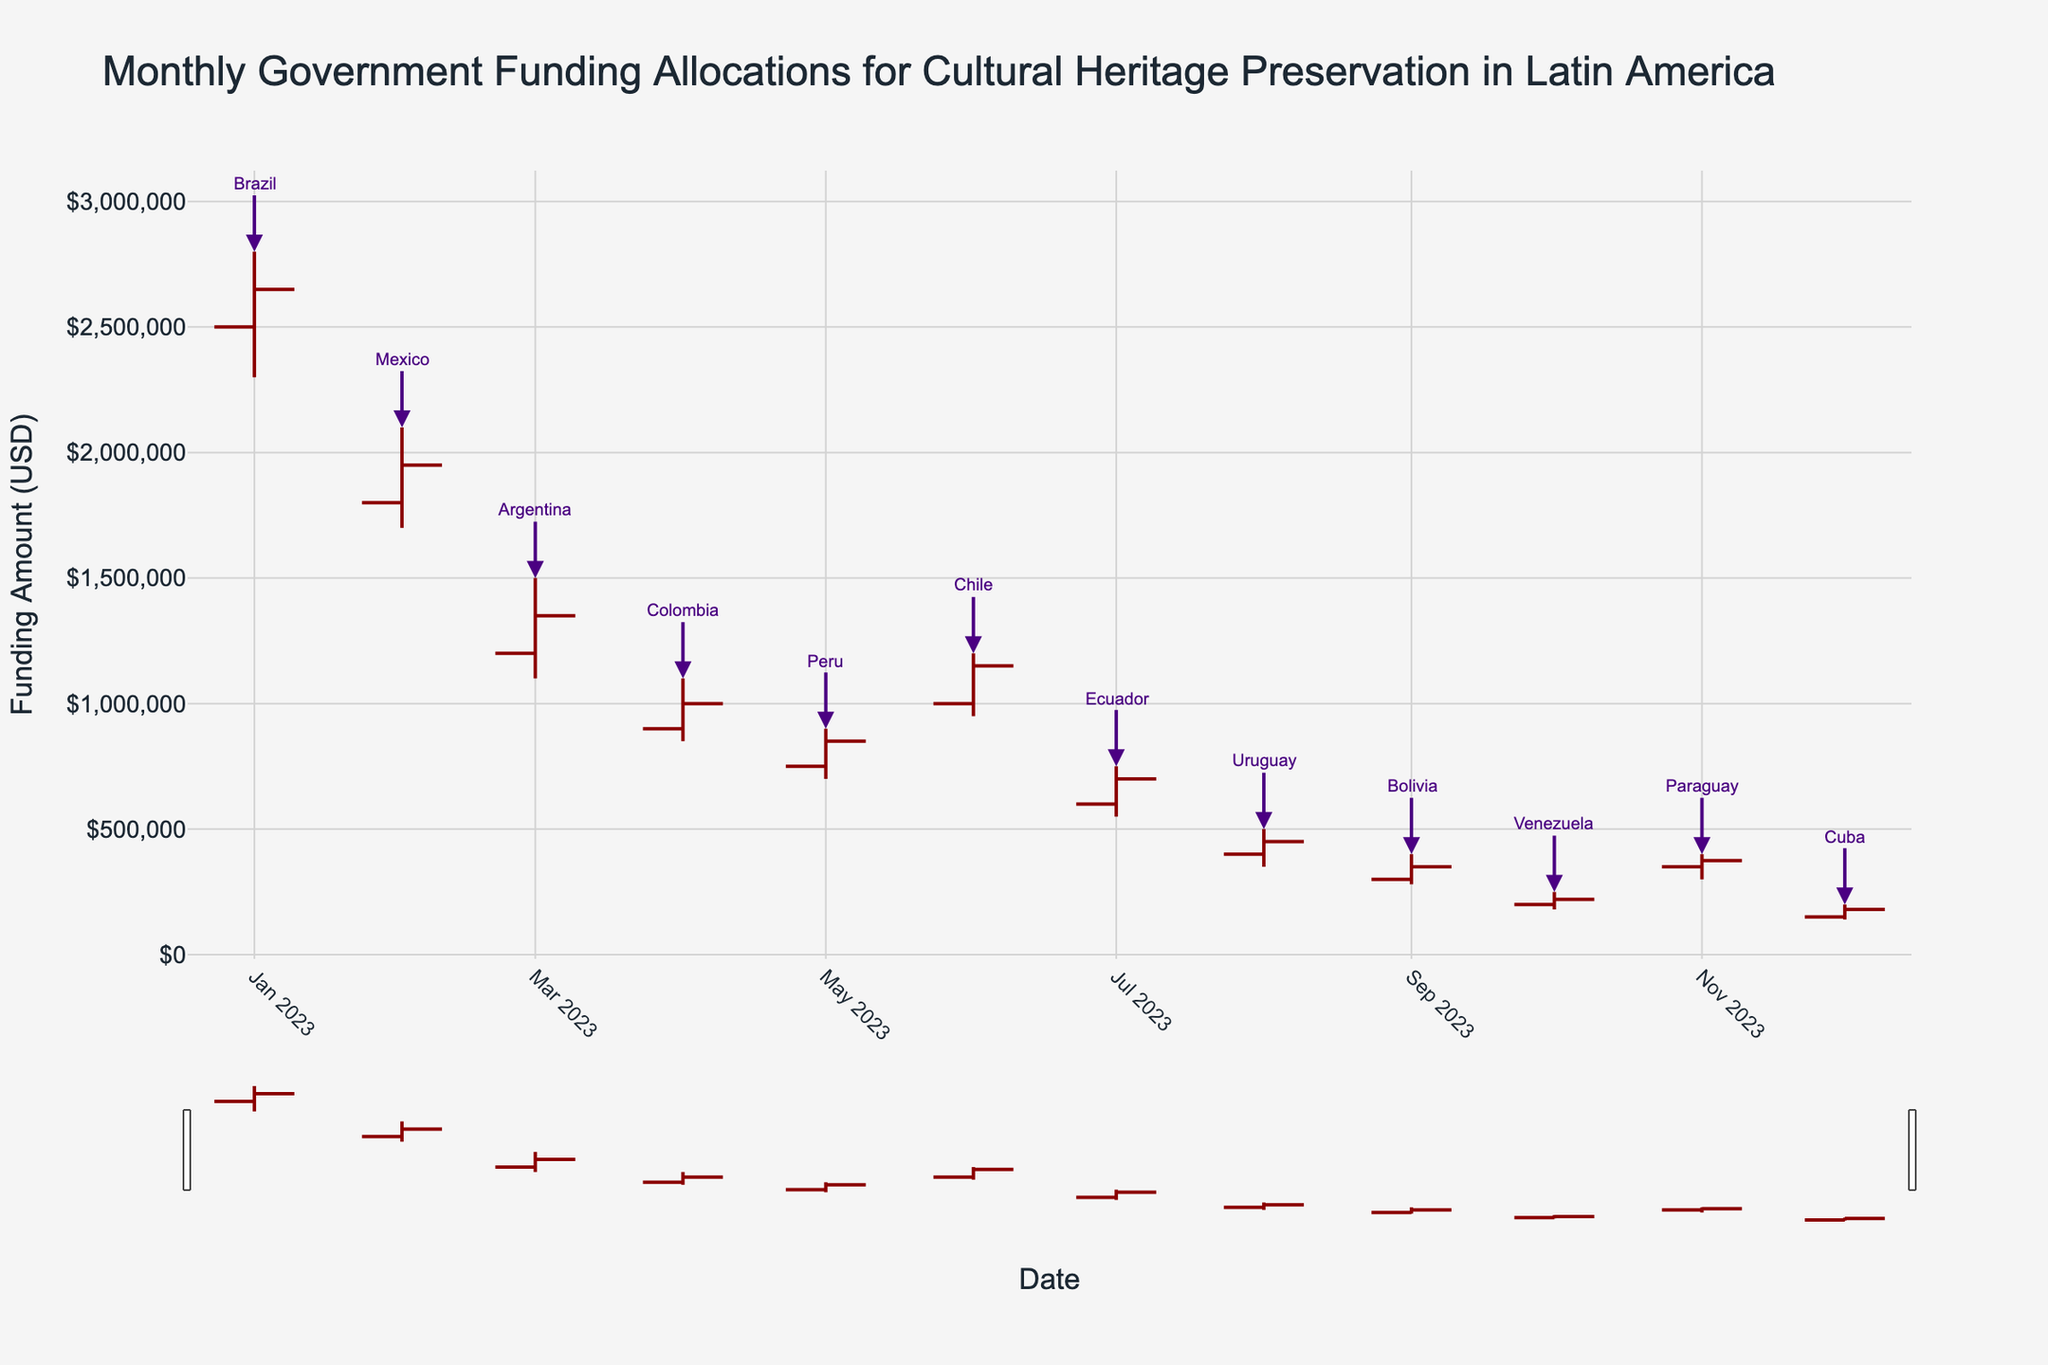What is the title of the figure? The title of the figure is located at the top center and is the descriptive heading for the chart. In this case, it reads: "Monthly Government Funding Allocations for Cultural Heritage Preservation in Latin America".
Answer: Monthly Government Funding Allocations for Cultural Heritage Preservation in Latin America Which country received the highest funding in 2023? Find the data point with the highest 'High' value on the chart. Brazil received the highest funding amount of $2,800,000 in January.
Answer: Brazil How many countries received less than $1,000,000 in funding at their lowest point? Check the 'Low' values in the OHLC chart for each country. Argentina, Colombia, Peru, Ecuador, Uruguay, Bolivia, Venezuela, Paraguay, and Cuba had 'Low' values below $1,000,000. That's 9 countries.
Answer: 9 Which month saw the lowest closing funding amount and which country does it belong to? Look for the smallest value in the 'Close' prices. December has the lowest close value of $180,000, which belongs to Cuba.
Answer: December, Cuba What is the difference between the highest funding allocation for Mexico and the closing allocation for Chile? Mexico's highest funding allocation is $2,100,000 in February. Chile's closing allocation is $1,150,000 in June. The difference is $2,100,000 - $1,150,000 = $950,000.
Answer: $950,000 Which country showed significant variability in funding allocation without seeing a drop below $1,000,000 at any point? Identify a country that has high variability in its OHLC data but maintains a 'Low' value above $1,000,000. Brazil fluctuates between $2,800,000 and $2,300,000 but does not drop below $1,000,000.
Answer: Brazil Would you say that the trend in funding is generally increasing or decreasing over the months? Overall, by observing the figure, funding amounts decrease progressively, especially from July to December.
Answer: Decreasing What was Colombia's highest recorded funding for 2023? Check the 'High' value for Colombia. Colombia's highest recorded funding is $1,100,000.
Answer: $1,100,000 How does the funding allocation trend for Paraguay compare with that for Bolivia? Both countries have relatively low funding allocations, but Paraguay's values are consistently higher than Bolivia's throughout 2023. Check their corresponding OHLC data points for detailed comparison.
Answer: Paraguay is consistently higher What notable observation can you make about the funding allocation for cultural heritage preservation in January compared to December? January shows the highest funding allocation overall, particularly with Brazil's peak, while December exhibits the lowest allocation with Cuba finishing at $180,000, indicating a significant drop over the year.
Answer: High in January, low in December 